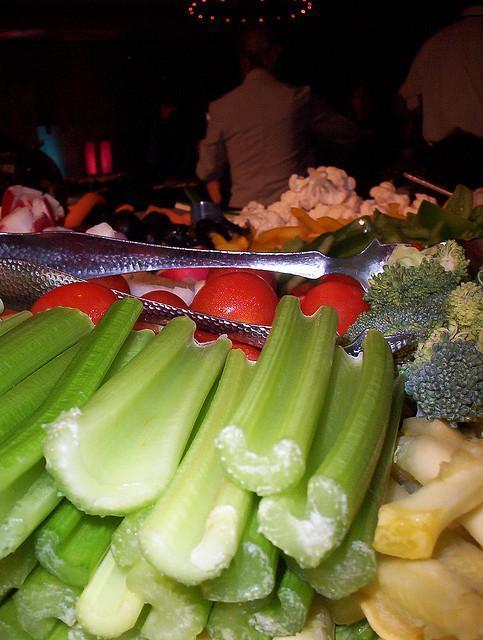How many people are visible?
Give a very brief answer. 3. How many airplanes are in this pic?
Give a very brief answer. 0. 